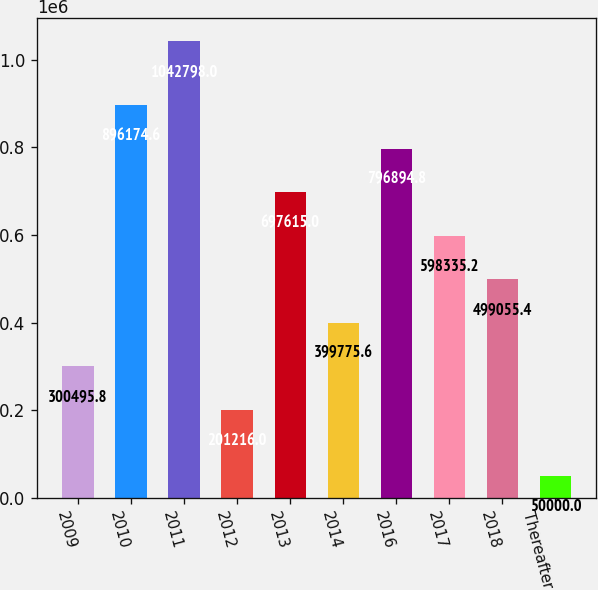Convert chart to OTSL. <chart><loc_0><loc_0><loc_500><loc_500><bar_chart><fcel>2009<fcel>2010<fcel>2011<fcel>2012<fcel>2013<fcel>2014<fcel>2016<fcel>2017<fcel>2018<fcel>Thereafter<nl><fcel>300496<fcel>896175<fcel>1.0428e+06<fcel>201216<fcel>697615<fcel>399776<fcel>796895<fcel>598335<fcel>499055<fcel>50000<nl></chart> 